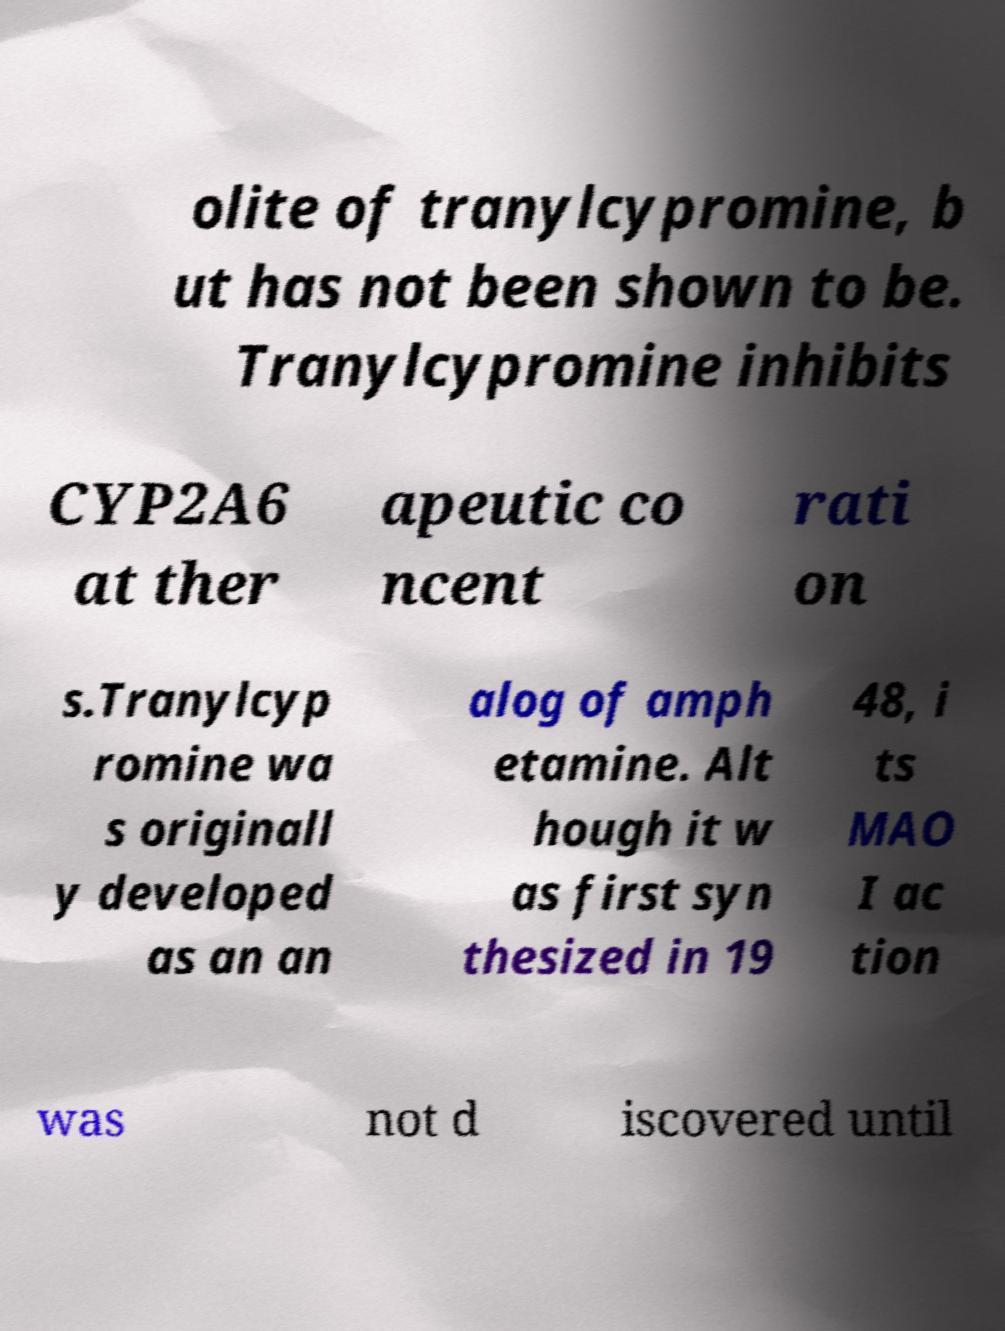Please read and relay the text visible in this image. What does it say? olite of tranylcypromine, b ut has not been shown to be. Tranylcypromine inhibits CYP2A6 at ther apeutic co ncent rati on s.Tranylcyp romine wa s originall y developed as an an alog of amph etamine. Alt hough it w as first syn thesized in 19 48, i ts MAO I ac tion was not d iscovered until 